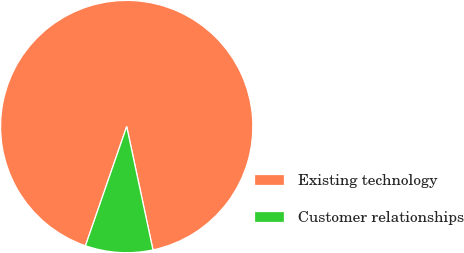<chart> <loc_0><loc_0><loc_500><loc_500><pie_chart><fcel>Existing technology<fcel>Customer relationships<nl><fcel>91.36%<fcel>8.64%<nl></chart> 